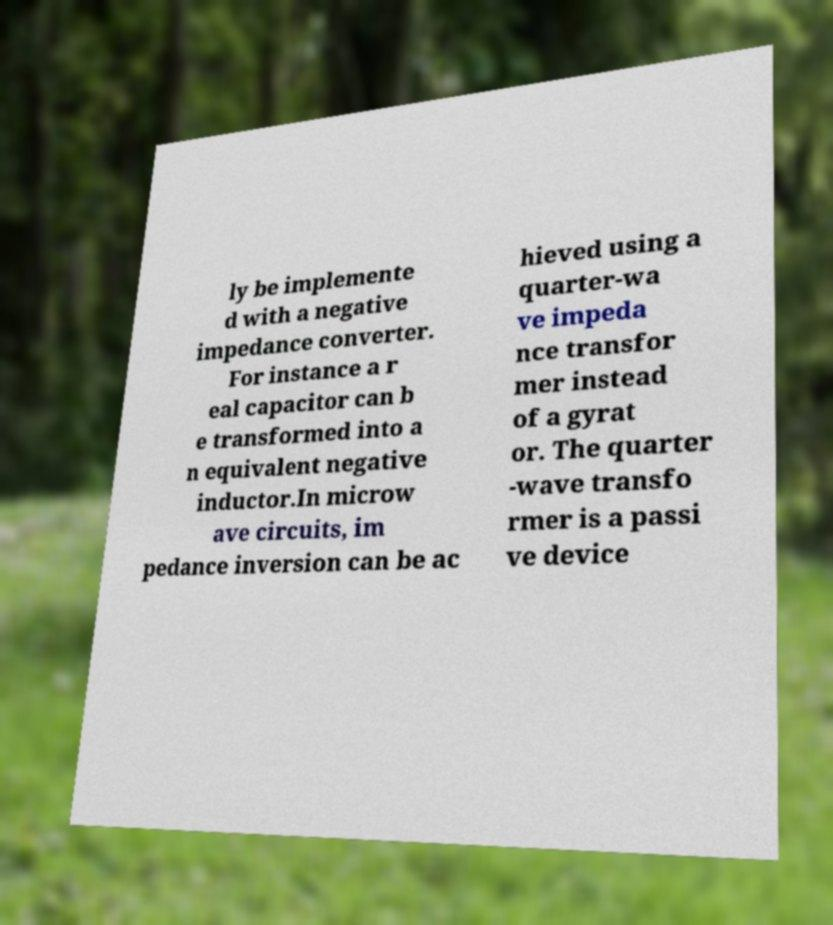What messages or text are displayed in this image? I need them in a readable, typed format. ly be implemente d with a negative impedance converter. For instance a r eal capacitor can b e transformed into a n equivalent negative inductor.In microw ave circuits, im pedance inversion can be ac hieved using a quarter-wa ve impeda nce transfor mer instead of a gyrat or. The quarter -wave transfo rmer is a passi ve device 